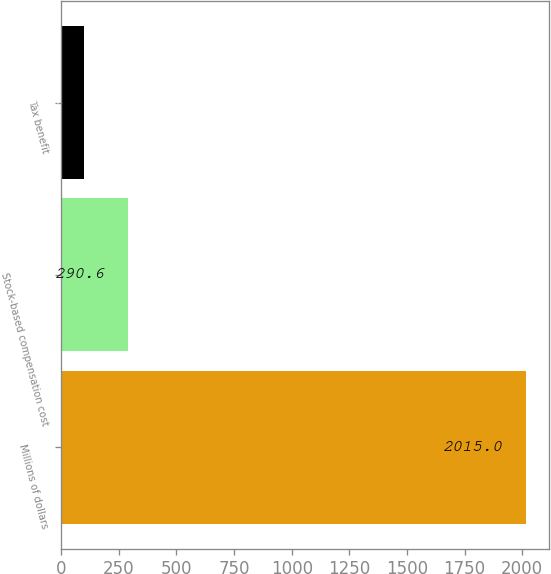Convert chart. <chart><loc_0><loc_0><loc_500><loc_500><bar_chart><fcel>Millions of dollars<fcel>Stock-based compensation cost<fcel>Tax benefit<nl><fcel>2015<fcel>290.6<fcel>99<nl></chart> 